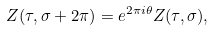<formula> <loc_0><loc_0><loc_500><loc_500>Z ( \tau , \sigma + 2 \pi ) = e ^ { 2 \pi i \theta } Z ( \tau , \sigma ) ,</formula> 